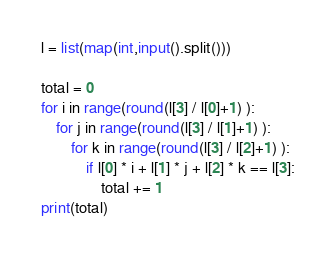<code> <loc_0><loc_0><loc_500><loc_500><_Python_>l = list(map(int,input().split()))

total = 0
for i in range(round(l[3] / l[0]+1) ):
    for j in range(round(l[3] / l[1]+1) ):
        for k in range(round(l[3] / l[2]+1) ):
            if l[0] * i + l[1] * j + l[2] * k == l[3]:
                total += 1
print(total)</code> 